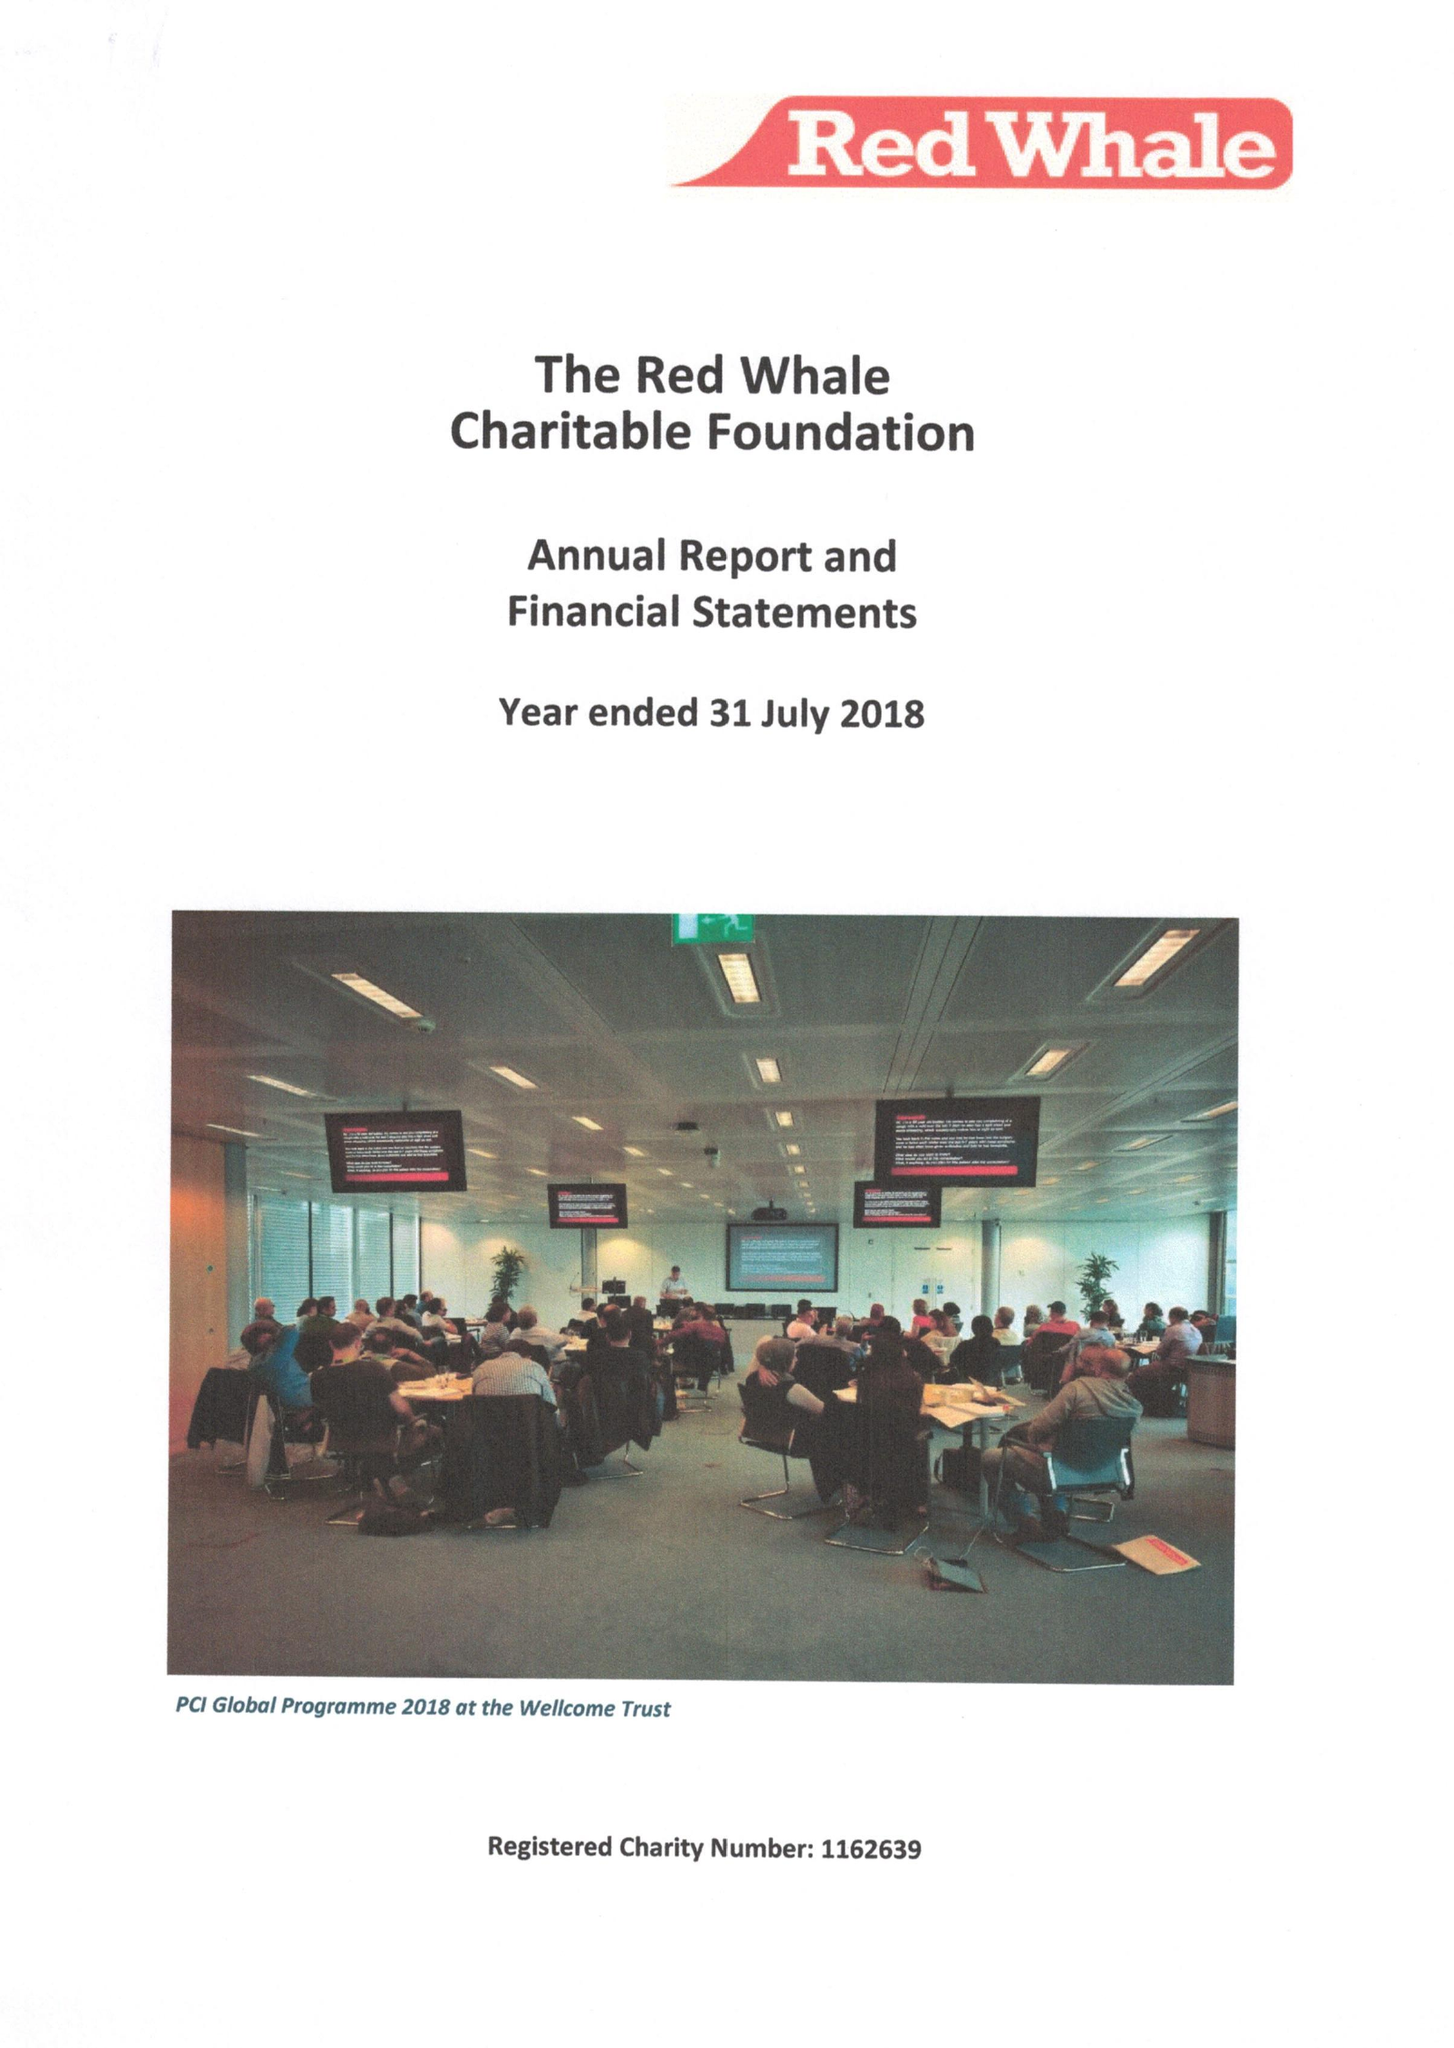What is the value for the address__street_line?
Answer the question using a single word or phrase. WHITEKNIGHTS ROAD 